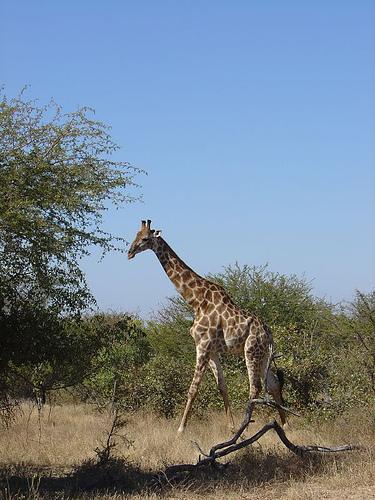How old is the giraffe?
Quick response, please. 7. Is the giraffe running?
Be succinct. No. Are there clouds?
Give a very brief answer. No. Is it day or night?
Answer briefly. Day. How many animals are visible in this photograph?
Answer briefly. 1. Is this a baby giraffe?
Keep it brief. No. Are there are lot of clouds?
Write a very short answer. No. Why are its front legs spread so wide?
Answer briefly. Walking. What animal is in the picture?
Concise answer only. Giraffe. Are the animals eating?
Short answer required. No. Are there any baby giraffes?
Keep it brief. No. What color is the grass?
Keep it brief. Brown. How many giraffes are there?
Short answer required. 1. Is there a storm coming?
Write a very short answer. No. 